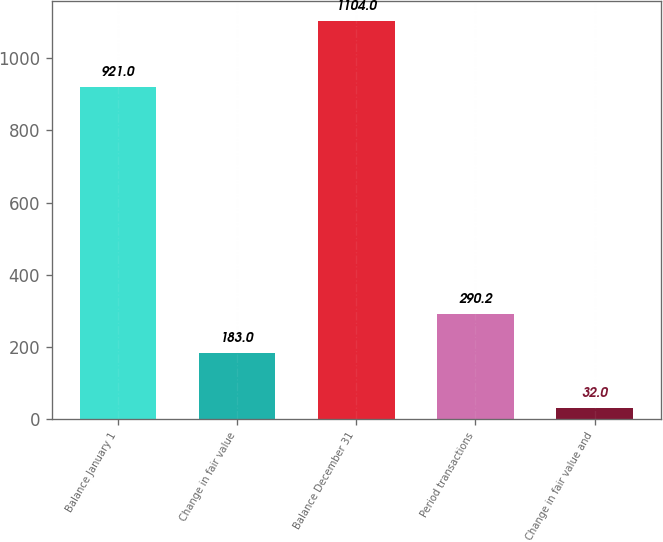Convert chart. <chart><loc_0><loc_0><loc_500><loc_500><bar_chart><fcel>Balance January 1<fcel>Change in fair value<fcel>Balance December 31<fcel>Period transactions<fcel>Change in fair value and<nl><fcel>921<fcel>183<fcel>1104<fcel>290.2<fcel>32<nl></chart> 